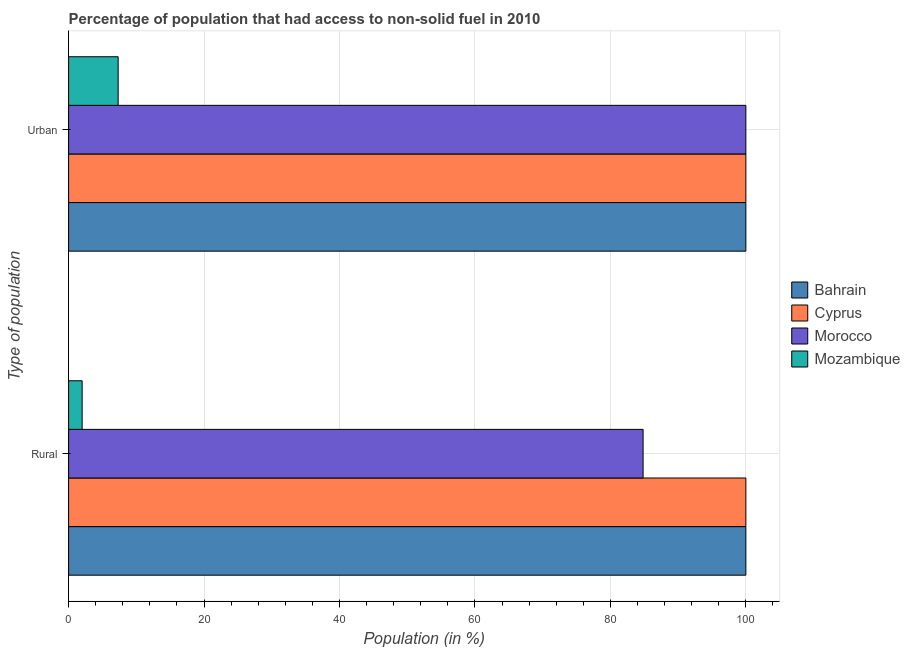How many groups of bars are there?
Your answer should be compact. 2. Are the number of bars on each tick of the Y-axis equal?
Your answer should be compact. Yes. How many bars are there on the 1st tick from the bottom?
Keep it short and to the point. 4. What is the label of the 1st group of bars from the top?
Offer a terse response. Urban. What is the rural population in Bahrain?
Provide a succinct answer. 100. Across all countries, what is the minimum rural population?
Your answer should be compact. 2. In which country was the rural population maximum?
Your response must be concise. Bahrain. In which country was the rural population minimum?
Provide a succinct answer. Mozambique. What is the total rural population in the graph?
Offer a very short reply. 286.82. What is the difference between the rural population in Morocco and that in Cyprus?
Your answer should be very brief. -15.18. What is the difference between the urban population in Bahrain and the rural population in Morocco?
Your answer should be very brief. 15.18. What is the average rural population per country?
Provide a short and direct response. 71.71. What is the difference between the urban population and rural population in Morocco?
Offer a very short reply. 15.18. What is the ratio of the urban population in Morocco to that in Cyprus?
Your response must be concise. 1. What does the 4th bar from the top in Urban represents?
Your answer should be compact. Bahrain. What does the 2nd bar from the bottom in Urban represents?
Provide a succinct answer. Cyprus. How many bars are there?
Provide a succinct answer. 8. Are all the bars in the graph horizontal?
Your response must be concise. Yes. How many countries are there in the graph?
Ensure brevity in your answer.  4. What is the difference between two consecutive major ticks on the X-axis?
Offer a terse response. 20. Are the values on the major ticks of X-axis written in scientific E-notation?
Keep it short and to the point. No. Does the graph contain any zero values?
Your response must be concise. No. Does the graph contain grids?
Offer a terse response. Yes. How are the legend labels stacked?
Keep it short and to the point. Vertical. What is the title of the graph?
Offer a terse response. Percentage of population that had access to non-solid fuel in 2010. What is the label or title of the X-axis?
Keep it short and to the point. Population (in %). What is the label or title of the Y-axis?
Provide a succinct answer. Type of population. What is the Population (in %) of Morocco in Rural?
Your response must be concise. 84.82. What is the Population (in %) of Mozambique in Rural?
Offer a terse response. 2. What is the Population (in %) in Mozambique in Urban?
Offer a terse response. 7.32. Across all Type of population, what is the maximum Population (in %) of Bahrain?
Your answer should be very brief. 100. Across all Type of population, what is the maximum Population (in %) in Cyprus?
Give a very brief answer. 100. Across all Type of population, what is the maximum Population (in %) in Morocco?
Your response must be concise. 100. Across all Type of population, what is the maximum Population (in %) of Mozambique?
Ensure brevity in your answer.  7.32. Across all Type of population, what is the minimum Population (in %) in Bahrain?
Give a very brief answer. 100. Across all Type of population, what is the minimum Population (in %) of Cyprus?
Provide a short and direct response. 100. Across all Type of population, what is the minimum Population (in %) in Morocco?
Make the answer very short. 84.82. Across all Type of population, what is the minimum Population (in %) of Mozambique?
Your response must be concise. 2. What is the total Population (in %) of Bahrain in the graph?
Ensure brevity in your answer.  200. What is the total Population (in %) in Cyprus in the graph?
Offer a very short reply. 200. What is the total Population (in %) of Morocco in the graph?
Offer a terse response. 184.82. What is the total Population (in %) of Mozambique in the graph?
Make the answer very short. 9.32. What is the difference between the Population (in %) in Morocco in Rural and that in Urban?
Ensure brevity in your answer.  -15.18. What is the difference between the Population (in %) in Mozambique in Rural and that in Urban?
Make the answer very short. -5.32. What is the difference between the Population (in %) of Bahrain in Rural and the Population (in %) of Morocco in Urban?
Offer a terse response. 0. What is the difference between the Population (in %) in Bahrain in Rural and the Population (in %) in Mozambique in Urban?
Offer a terse response. 92.68. What is the difference between the Population (in %) of Cyprus in Rural and the Population (in %) of Mozambique in Urban?
Your answer should be very brief. 92.68. What is the difference between the Population (in %) in Morocco in Rural and the Population (in %) in Mozambique in Urban?
Offer a terse response. 77.51. What is the average Population (in %) of Bahrain per Type of population?
Ensure brevity in your answer.  100. What is the average Population (in %) of Morocco per Type of population?
Give a very brief answer. 92.41. What is the average Population (in %) of Mozambique per Type of population?
Offer a terse response. 4.66. What is the difference between the Population (in %) in Bahrain and Population (in %) in Morocco in Rural?
Make the answer very short. 15.18. What is the difference between the Population (in %) in Bahrain and Population (in %) in Mozambique in Rural?
Provide a short and direct response. 98. What is the difference between the Population (in %) in Cyprus and Population (in %) in Morocco in Rural?
Offer a terse response. 15.18. What is the difference between the Population (in %) in Cyprus and Population (in %) in Mozambique in Rural?
Make the answer very short. 98. What is the difference between the Population (in %) in Morocco and Population (in %) in Mozambique in Rural?
Your response must be concise. 82.83. What is the difference between the Population (in %) of Bahrain and Population (in %) of Morocco in Urban?
Your answer should be compact. 0. What is the difference between the Population (in %) in Bahrain and Population (in %) in Mozambique in Urban?
Make the answer very short. 92.68. What is the difference between the Population (in %) in Cyprus and Population (in %) in Mozambique in Urban?
Give a very brief answer. 92.68. What is the difference between the Population (in %) of Morocco and Population (in %) of Mozambique in Urban?
Provide a succinct answer. 92.68. What is the ratio of the Population (in %) in Bahrain in Rural to that in Urban?
Your answer should be very brief. 1. What is the ratio of the Population (in %) of Morocco in Rural to that in Urban?
Your answer should be compact. 0.85. What is the ratio of the Population (in %) of Mozambique in Rural to that in Urban?
Offer a very short reply. 0.27. What is the difference between the highest and the second highest Population (in %) of Bahrain?
Your answer should be compact. 0. What is the difference between the highest and the second highest Population (in %) in Morocco?
Ensure brevity in your answer.  15.18. What is the difference between the highest and the second highest Population (in %) of Mozambique?
Give a very brief answer. 5.32. What is the difference between the highest and the lowest Population (in %) in Morocco?
Your answer should be very brief. 15.18. What is the difference between the highest and the lowest Population (in %) of Mozambique?
Your response must be concise. 5.32. 